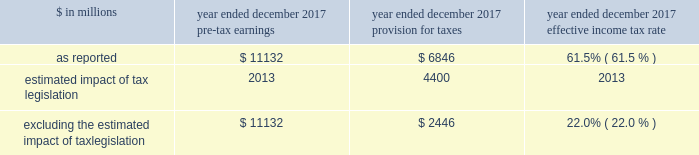The goldman sachs group , inc .
And subsidiaries management 2019s discussion and analysis as of december 2017 , total staff increased 6% ( 6 % ) compared with december 2016 , reflecting investments in technology and marcus , and support of our regulatory efforts .
2016 versus 2015 .
Operating expenses in the consolidated statements of earnings were $ 20.30 billion for 2016 , 19% ( 19 % ) lower than 2015 .
Compensation and benefits expenses in the consolidated statements of earnings were $ 11.65 billion for 2016 , 8% ( 8 % ) lower than 2015 , reflecting a decrease in net revenues and the impact of expense savings initiatives .
The ratio of compensation and benefits to net revenues for 2016 was 38.1% ( 38.1 % ) compared with 37.5% ( 37.5 % ) for 2015 .
Non-compensation expenses in the consolidated statements of earnings were $ 8.66 billion for 2016 , 30% ( 30 % ) lower than 2015 , primarily due to significantly lower net provisions for mortgage-related litigation and regulatory matters , which are included in other expenses .
In addition , market development expenses and professional fees were lower compared with 2015 , reflecting expense savings initiatives .
Net provisions for litigation and regulatory proceedings for 2016 were $ 396 million compared with $ 4.01 billion for 2015 ( 2015 primarily related to net provisions for mortgage-related matters ) .
2016 included a $ 114 million charitable contribution to goldman sachs gives .
Compensation was reduced to fund this charitable contribution to goldman sachs gives .
We ask our participating managing directors to make recommendations regarding potential charitable recipients for this contribution .
As of december 2016 , total staff decreased 7% ( 7 % ) compared with december 2015 , due to expense savings initiatives .
Provision for taxes the effective income tax rate for 2017 was 61.5% ( 61.5 % ) , up from 28.2% ( 28.2 % ) for 2016 .
The increase compared with 2016 reflected the estimated impact of tax legislation , which was enacted on december 22 , 2017 and , among other things , lowers u.s .
Corporate income tax rates as of january 1 , 2018 , implements a territorial tax system and imposes a repatriation tax on deemed repatriated earnings of foreign subsidiaries .
The estimated impact of tax legislation was an increase in income tax expense of $ 4.40 billion , of which $ 3.32 billion was due to the repatriation tax and $ 1.08 billion was due to the effects of the implementation of the territorial tax system and the remeasurement of u.s .
Deferred tax assets at lower enacted corporate tax rates .
The impact of tax legislation may differ from this estimate , possibly materially , due to , among other things , ( i ) refinement of our calculations based on updated information , ( ii ) changes in interpretations and assumptions , ( iii ) guidance that may be issued and ( iv ) actions we may take as a result of tax legislation .
Excluding the estimated impact of tax legislation , the effective income tax rate for 2017 was 22.0% ( 22.0 % ) , down from 28.2% ( 28.2 % ) for 2016 .
This decrease was primarily due to tax benefits on the settlement of employee share-based awards in accordance with asu no .
2016-09 .
The impact of these settlements in 2017 was a reduction to our provision for taxes of $ 719 million and a reduction in our effective income tax rate of 6.4 percentage points .
See note 3 to the consolidated financial statements for further information about this asu .
The effective income tax rate , excluding the estimated impact of tax legislation , is a non-gaap measure and may not be comparable to similar non-gaap measures used by other companies .
We believe that presenting our effective income tax rate , excluding the estimated impact of tax legislation is meaningful , as excluding this item increases the comparability of period-to-period results .
The table below presents the calculation of the effective income tax rate , excluding the estimated impact of tax legislation. .
Excluding the estimated impact of tax legislation $ 11132 $ 2446 22.0% ( 22.0 % ) the effective income tax rate for 2016 was 28.2% ( 28.2 % ) , down from 30.7% ( 30.7 % ) for 2015 .
The decline compared with 2015 was primarily due to the impact of non-deductible provisions for mortgage-related litigation and regulatory matters in 2015 , partially offset by the impact of changes in tax law on deferred tax assets , the mix of earnings and an increase related to higher enacted tax rates impacting certain of our u.k .
Subsidiaries in 2016 .
Effective january 1 , 2018 , tax legislation reduced the u.s .
Corporate tax rate to 21 percent , eliminated tax deductions for certain expenses and enacted two new taxes , base erosion and anti-abuse tax ( beat ) and global intangible low taxed income ( gilti ) .
Beat is an alternative minimum tax that applies to banks that pay more than 2 percent of total deductible expenses to certain foreign subsidiaries .
Gilti is a 10.5 percent tax , before allowable credits for foreign taxes paid , on the annual earnings and profits of certain foreign subsidiaries .
Based on our current understanding of these rules , the impact of beat and gilti is not expected to be material to our effective income tax rate .
Goldman sachs 2017 form 10-k 55 .
For 2017 , the estimated impact of tax legislation was what percent of the total as reported income tax provisions? 
Computations: (4400 / 6846)
Answer: 0.64271. 